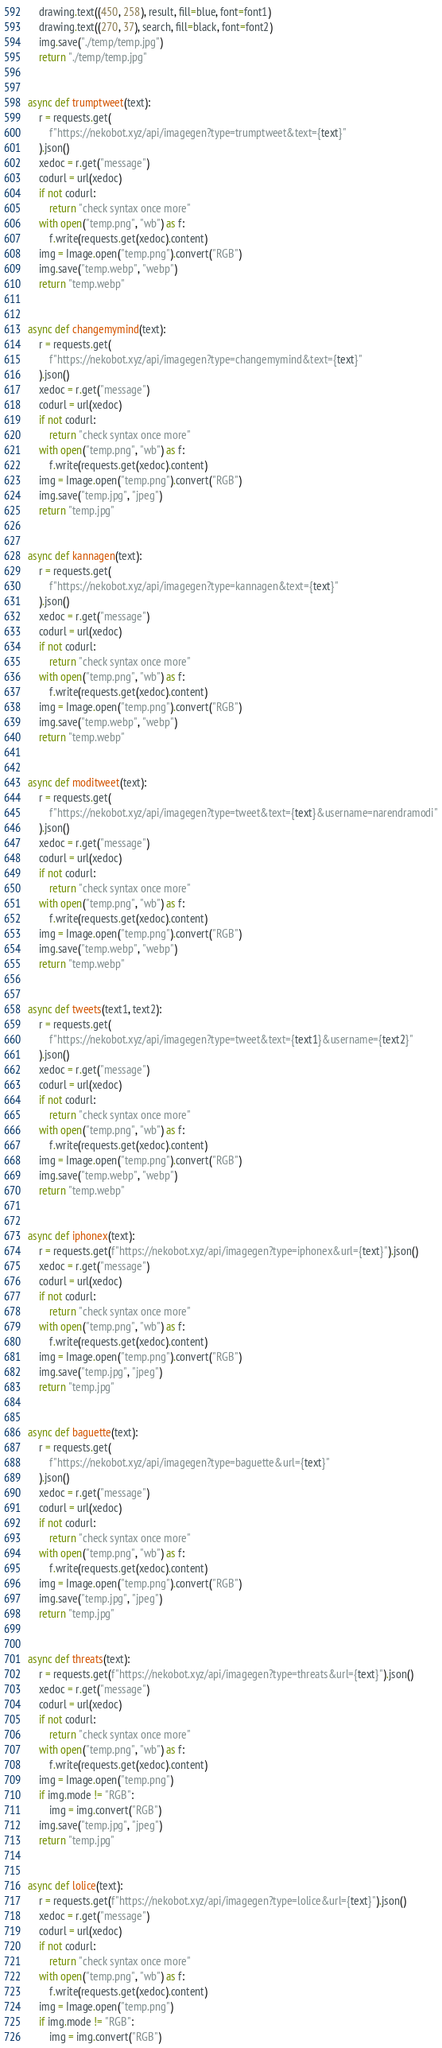Convert code to text. <code><loc_0><loc_0><loc_500><loc_500><_Python_>    drawing.text((450, 258), result, fill=blue, font=font1)
    drawing.text((270, 37), search, fill=black, font=font2)
    img.save("./temp/temp.jpg")
    return "./temp/temp.jpg"


async def trumptweet(text):
    r = requests.get(
        f"https://nekobot.xyz/api/imagegen?type=trumptweet&text={text}"
    ).json()
    xedoc = r.get("message")
    codurl = url(xedoc)
    if not codurl:
        return "check syntax once more"
    with open("temp.png", "wb") as f:
        f.write(requests.get(xedoc).content)
    img = Image.open("temp.png").convert("RGB")
    img.save("temp.webp", "webp")
    return "temp.webp"


async def changemymind(text):
    r = requests.get(
        f"https://nekobot.xyz/api/imagegen?type=changemymind&text={text}"
    ).json()
    xedoc = r.get("message")
    codurl = url(xedoc)
    if not codurl:
        return "check syntax once more"
    with open("temp.png", "wb") as f:
        f.write(requests.get(xedoc).content)
    img = Image.open("temp.png").convert("RGB")
    img.save("temp.jpg", "jpeg")
    return "temp.jpg"


async def kannagen(text):
    r = requests.get(
        f"https://nekobot.xyz/api/imagegen?type=kannagen&text={text}"
    ).json()
    xedoc = r.get("message")
    codurl = url(xedoc)
    if not codurl:
        return "check syntax once more"
    with open("temp.png", "wb") as f:
        f.write(requests.get(xedoc).content)
    img = Image.open("temp.png").convert("RGB")
    img.save("temp.webp", "webp")
    return "temp.webp"


async def moditweet(text):
    r = requests.get(
        f"https://nekobot.xyz/api/imagegen?type=tweet&text={text}&username=narendramodi"
    ).json()
    xedoc = r.get("message")
    codurl = url(xedoc)
    if not codurl:
        return "check syntax once more"
    with open("temp.png", "wb") as f:
        f.write(requests.get(xedoc).content)
    img = Image.open("temp.png").convert("RGB")
    img.save("temp.webp", "webp")
    return "temp.webp"


async def tweets(text1, text2):
    r = requests.get(
        f"https://nekobot.xyz/api/imagegen?type=tweet&text={text1}&username={text2}"
    ).json()
    xedoc = r.get("message")
    codurl = url(xedoc)
    if not codurl:
        return "check syntax once more"
    with open("temp.png", "wb") as f:
        f.write(requests.get(xedoc).content)
    img = Image.open("temp.png").convert("RGB")
    img.save("temp.webp", "webp")
    return "temp.webp"


async def iphonex(text):
    r = requests.get(f"https://nekobot.xyz/api/imagegen?type=iphonex&url={text}").json()
    xedoc = r.get("message")
    codurl = url(xedoc)
    if not codurl:
        return "check syntax once more"
    with open("temp.png", "wb") as f:
        f.write(requests.get(xedoc).content)
    img = Image.open("temp.png").convert("RGB")
    img.save("temp.jpg", "jpeg")
    return "temp.jpg"


async def baguette(text):
    r = requests.get(
        f"https://nekobot.xyz/api/imagegen?type=baguette&url={text}"
    ).json()
    xedoc = r.get("message")
    codurl = url(xedoc)
    if not codurl:
        return "check syntax once more"
    with open("temp.png", "wb") as f:
        f.write(requests.get(xedoc).content)
    img = Image.open("temp.png").convert("RGB")
    img.save("temp.jpg", "jpeg")
    return "temp.jpg"


async def threats(text):
    r = requests.get(f"https://nekobot.xyz/api/imagegen?type=threats&url={text}").json()
    xedoc = r.get("message")
    codurl = url(xedoc)
    if not codurl:
        return "check syntax once more"
    with open("temp.png", "wb") as f:
        f.write(requests.get(xedoc).content)
    img = Image.open("temp.png")
    if img.mode != "RGB":
        img = img.convert("RGB")
    img.save("temp.jpg", "jpeg")
    return "temp.jpg"


async def lolice(text):
    r = requests.get(f"https://nekobot.xyz/api/imagegen?type=lolice&url={text}").json()
    xedoc = r.get("message")
    codurl = url(xedoc)
    if not codurl:
        return "check syntax once more"
    with open("temp.png", "wb") as f:
        f.write(requests.get(xedoc).content)
    img = Image.open("temp.png")
    if img.mode != "RGB":
        img = img.convert("RGB")</code> 